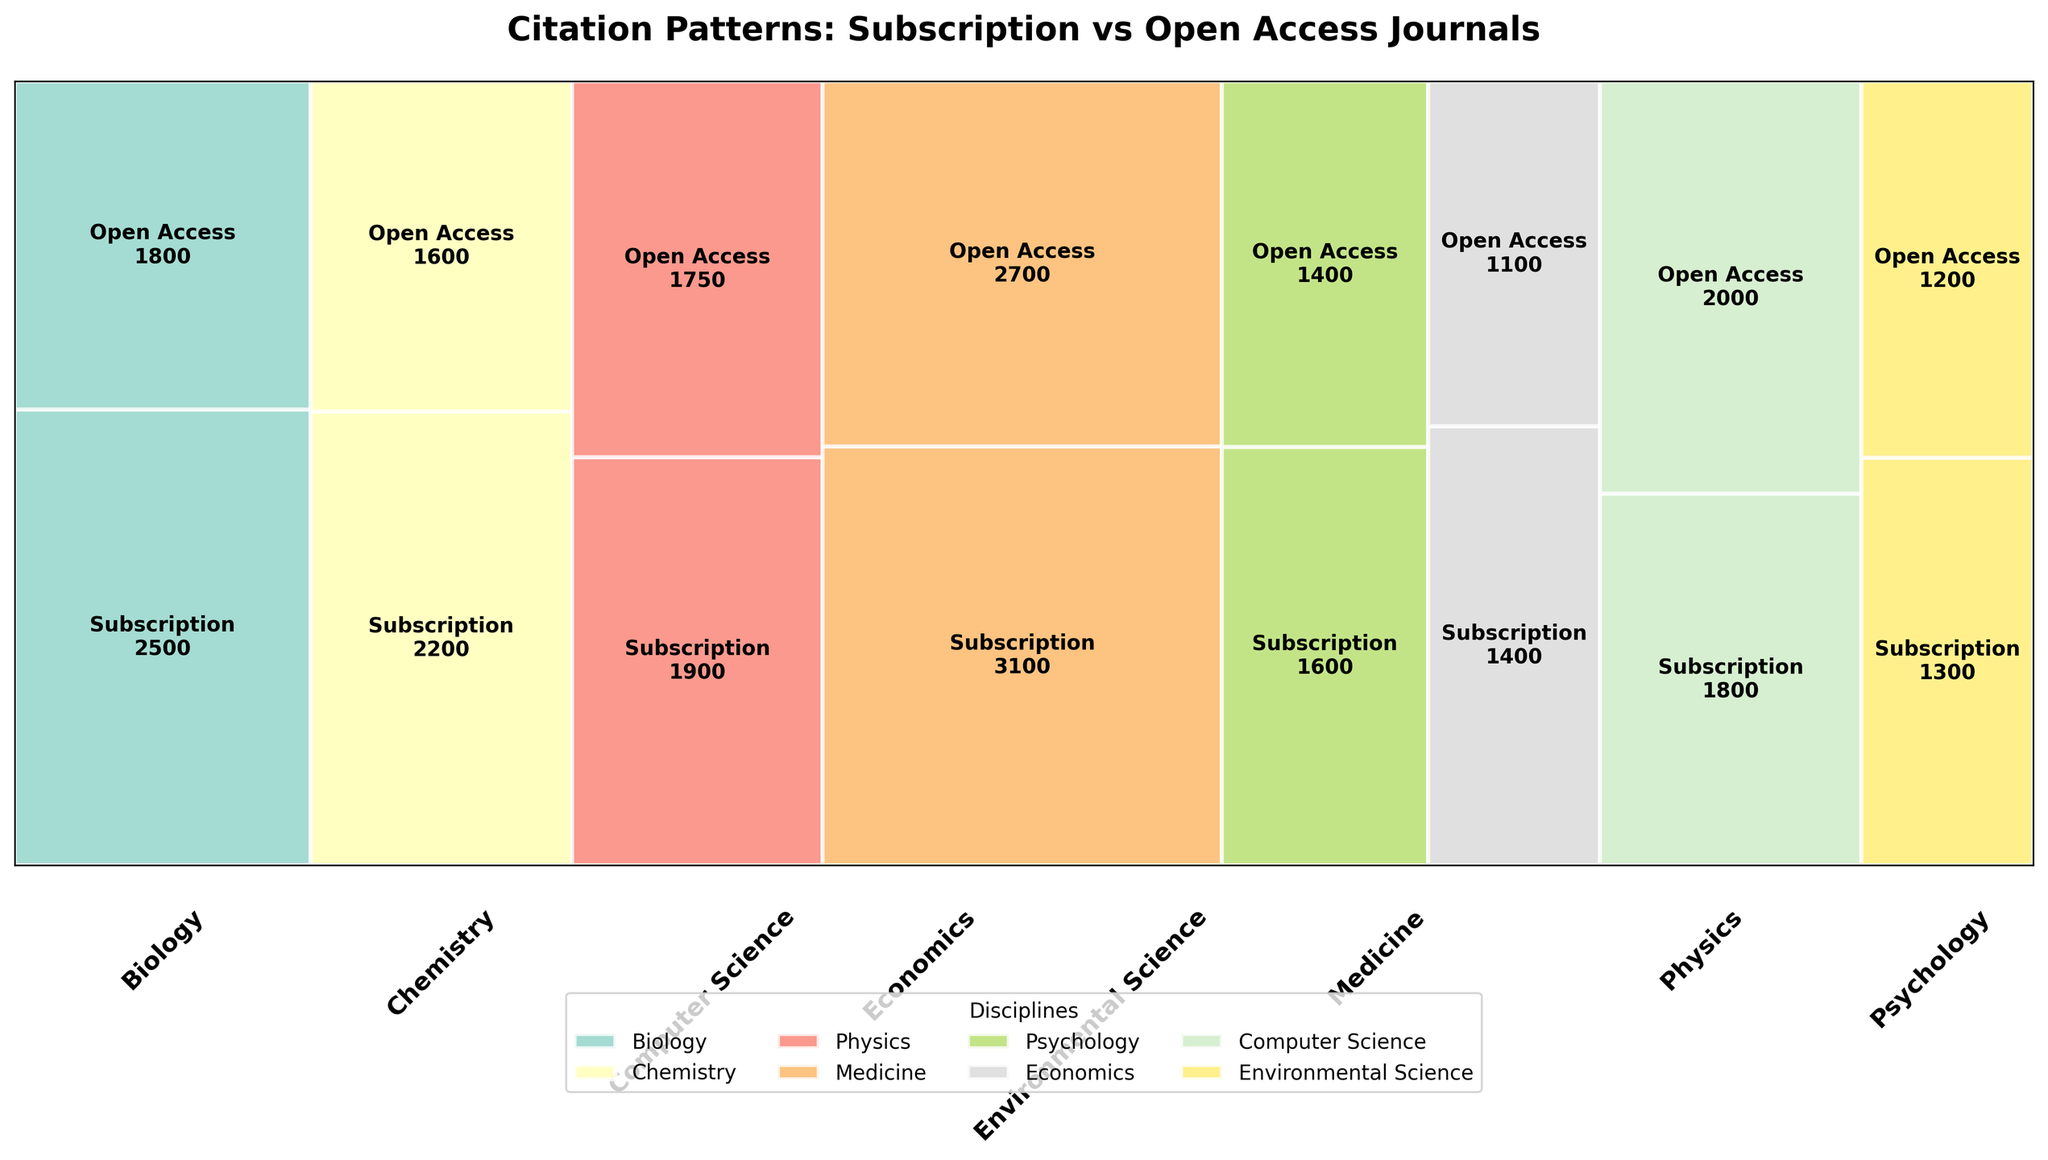What is the title of the plot? The title is often found at the top of the plot, providing a summary of what the plot is about. In this case, the title is "Citation Patterns: Subscription vs Open Access Journals".
Answer: Citation Patterns: Subscription vs Open Access Journals What discipline has the highest total citation count for subscription-based journals? To answer this, look at the rectangles corresponding to subscription-based journals in different disciplines and find the one with the highest number. Medicine has 3100 citations, which is the highest among all disciplines.
Answer: Medicine Among the disciplines, which one has a higher citation count in open access journals compared to subscription-based journals? Check the height of the rectangles for each discipline. Only in Computer Science does the open access section have a greater height than the subscription-based section, indicating a higher citation count.
Answer: Computer Science How many disciplines have more citations in subscription-based journals than in open access journals? Compare the citation counts for both journal types across all disciplines. There are 7 disciplines where subscription-based journals have more citations: Biology, Chemistry, Physics, Medicine, Psychology, Economics, Environmental Science.
Answer: 7 What is the proportion of citations in subscription-based journals relative to open access journals in Biology? Calculate the fraction of citations for subscription journals relative to open access in Biology: 2500 (Subscription) / 1800 (Open Access). This equals approximately 1.39.
Answer: 1.39 In which discipline is the citation count difference between subscription-based journals and open access journals the smallest? Find the discipline where the absolute difference between citations in subscription-based and open access journals is the smallest. For Physics, the difference is 1900 (Subscription) - 1750 (Open Access) = 150, which is the smallest among all disciplines.
Answer: Physics What is the average citation count for open access journals across all disciplines? Sum the citation counts for open access journals across all disciplines and divide by the number of disciplines. The total is 1800+1600+1750+2700+1400+1100+2000+1200 = 13550. Dividing by 8 gives an average of 1693.75.
Answer: 1693.75 Which has more overall citations: subscription-based journals or open access journals? Add the total citation counts for subscription-based and open access journals. Subscription: 2500+2200+1900+3100+1600+1400+1800+1300 = 15800. Open Access: 13550. Subscription-based journals have more overall citations.
Answer: Subscription-based journals What is the citation count difference between subscription-based and open access journals in Medicine? Subtract the citation count of open access journals from subscription-based journals in Medicine: 3100 - 2700 = 400.
Answer: 400 